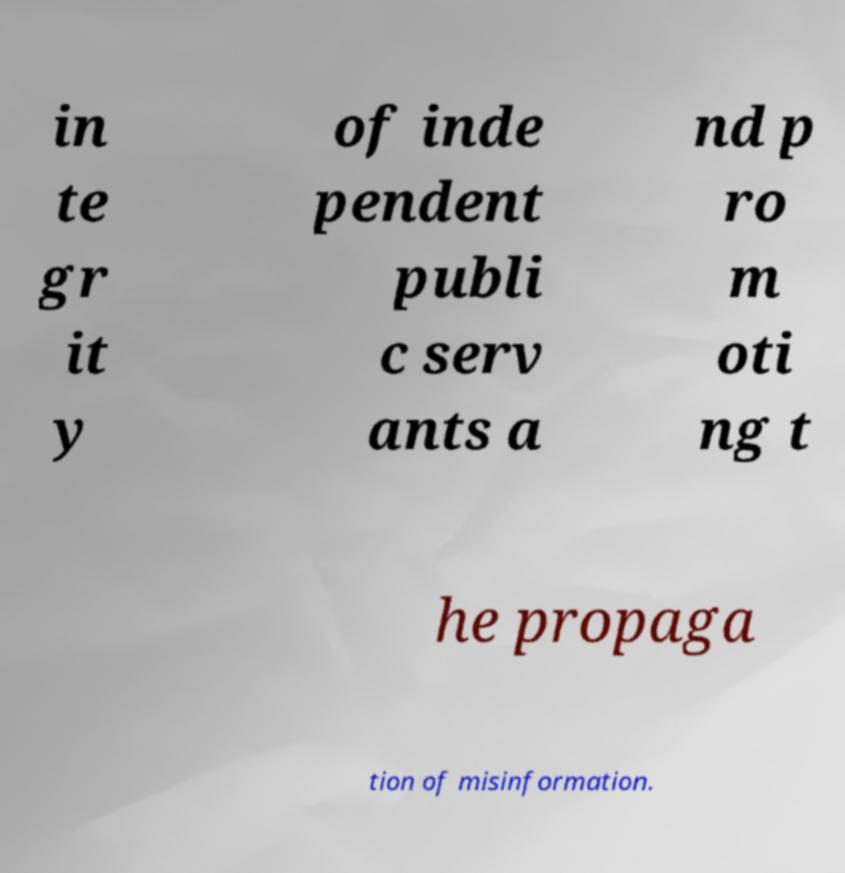For documentation purposes, I need the text within this image transcribed. Could you provide that? in te gr it y of inde pendent publi c serv ants a nd p ro m oti ng t he propaga tion of misinformation. 